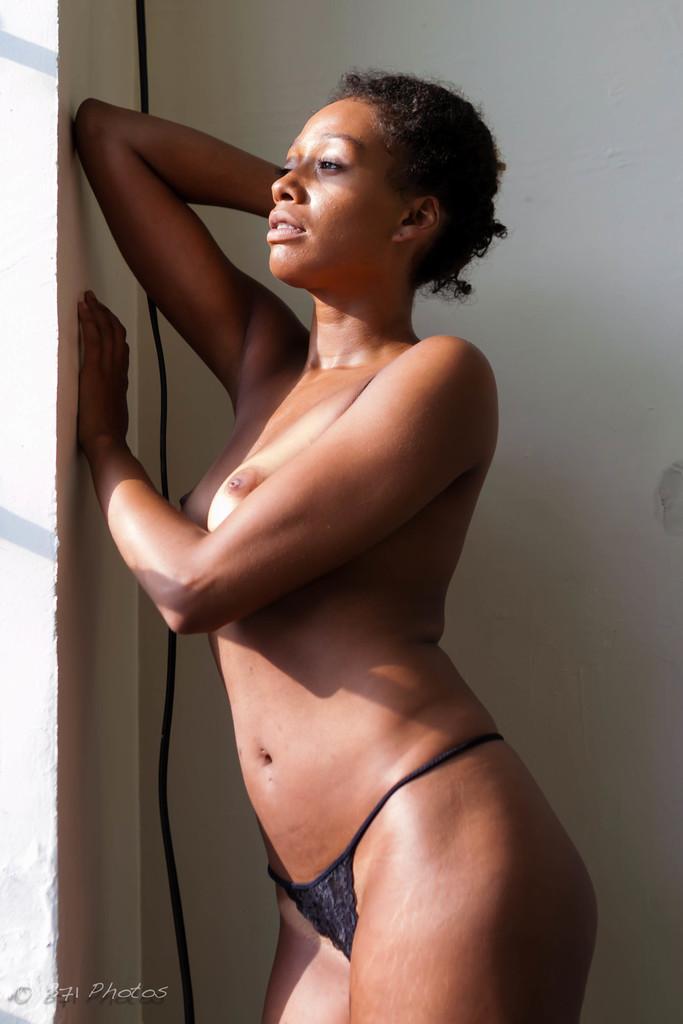Describe this image in one or two sentences. In this image I can see a person standing and wearing black dress. Back I can see the white wall. 